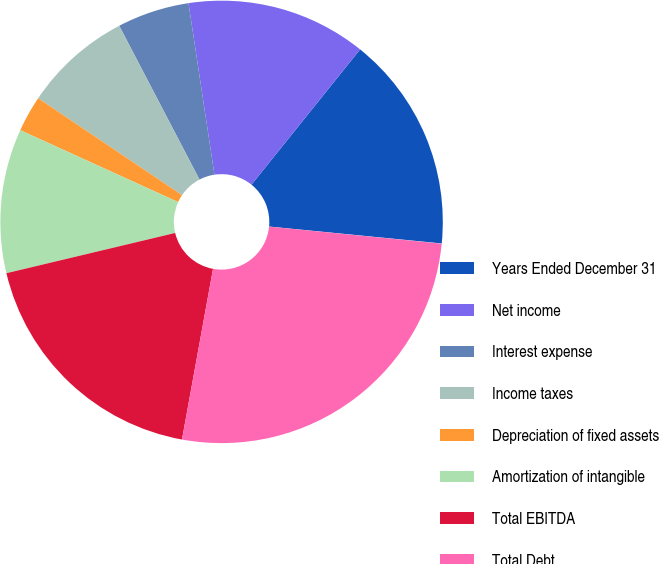Convert chart to OTSL. <chart><loc_0><loc_0><loc_500><loc_500><pie_chart><fcel>Years Ended December 31<fcel>Net income<fcel>Interest expense<fcel>Income taxes<fcel>Depreciation of fixed assets<fcel>Amortization of intangible<fcel>Total EBITDA<fcel>Total Debt<fcel>Total debt-to-EBITDA ratio<nl><fcel>15.79%<fcel>13.16%<fcel>5.27%<fcel>7.9%<fcel>2.64%<fcel>10.53%<fcel>18.41%<fcel>26.3%<fcel>0.01%<nl></chart> 